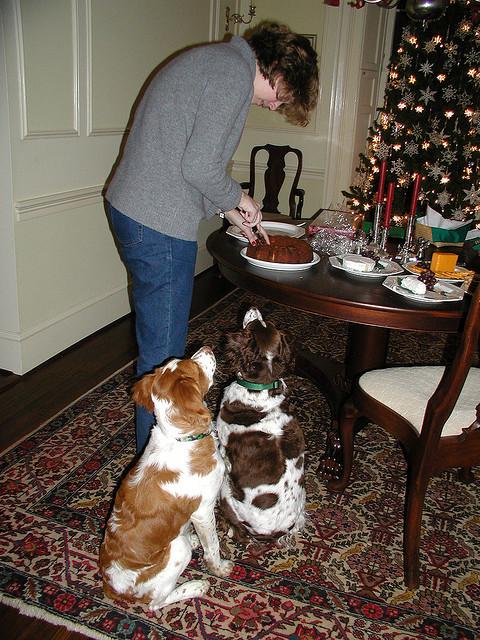How many dogs are there?
Keep it brief. 2. What are the dogs waiting for?
Short answer required. Food. What are they doing?
Be succinct. Begging. Is it Christmas?
Give a very brief answer. Yes. 